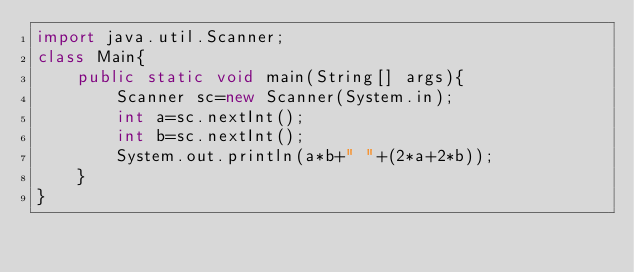<code> <loc_0><loc_0><loc_500><loc_500><_Java_>import java.util.Scanner;
class Main{
    public static void main(String[] args){
        Scanner sc=new Scanner(System.in);
        int a=sc.nextInt();
        int b=sc.nextInt();
        System.out.println(a*b+" "+(2*a+2*b));
    }
}
</code> 